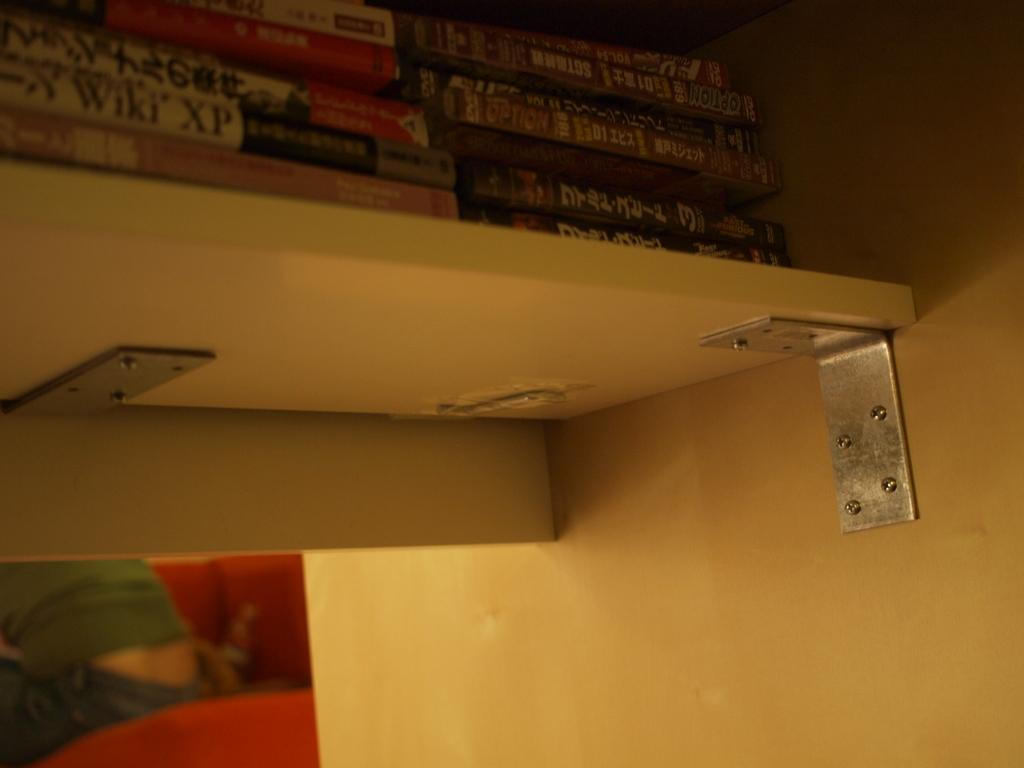What type of space is depicted in the image? The image is of a room. What can be found in the room? There are books in a shelf in the room. Is there anyone present in the room? Yes, there is a person sitting on a sofa in the room. How many dolls are being washed in the room? There are no dolls or washing activities depicted in the image. 